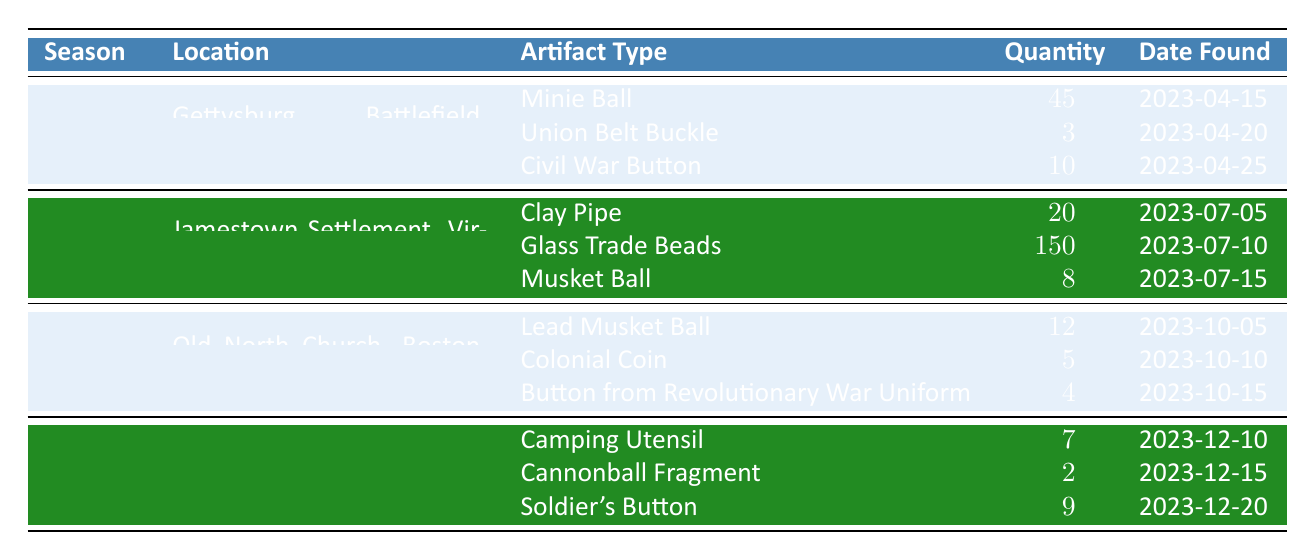What type of artifact was found the most in the summer? The table indicates that the type of artifact with the highest quantity found in summer was "Glass Trade Beads," with a total of 150.
Answer: Glass Trade Beads How many total artifacts were found in the fall? To find the total artifacts found in fall, add up the quantities: 12 (Lead Musket Ball) + 5 (Colonial Coin) + 4 (Button from Revolutionary War Uniform) = 21.
Answer: 21 Did any artifacts from Spring have more than 10 pieces found? Yes, the "Minie Ball" had 45 pieces found, which is more than 10.
Answer: Yes Which season had the lowest number of artifacts found? In winter, 7 (Camping Utensil), 2 (Cannonball Fragment), and 9 (Soldier's Button) were found. Adding those gives a total of 18. In spring, a total of 58 was found; in summer, a total of 178; and in fall, a total of 21. The lowest is winter with 18.
Answer: Winter What is the difference in the total quantity of artifacts found between summer and winter? First, calculate the total for summer: 20 (Clay Pipe) + 150 (Glass Trade Beads) + 8 (Musket Ball) = 178. Then calculate the total for winter: 7 (Camping Utensil) + 2 (Cannonball Fragment) + 9 (Soldier's Button) = 18. The difference is 178 - 18 = 160.
Answer: 160 